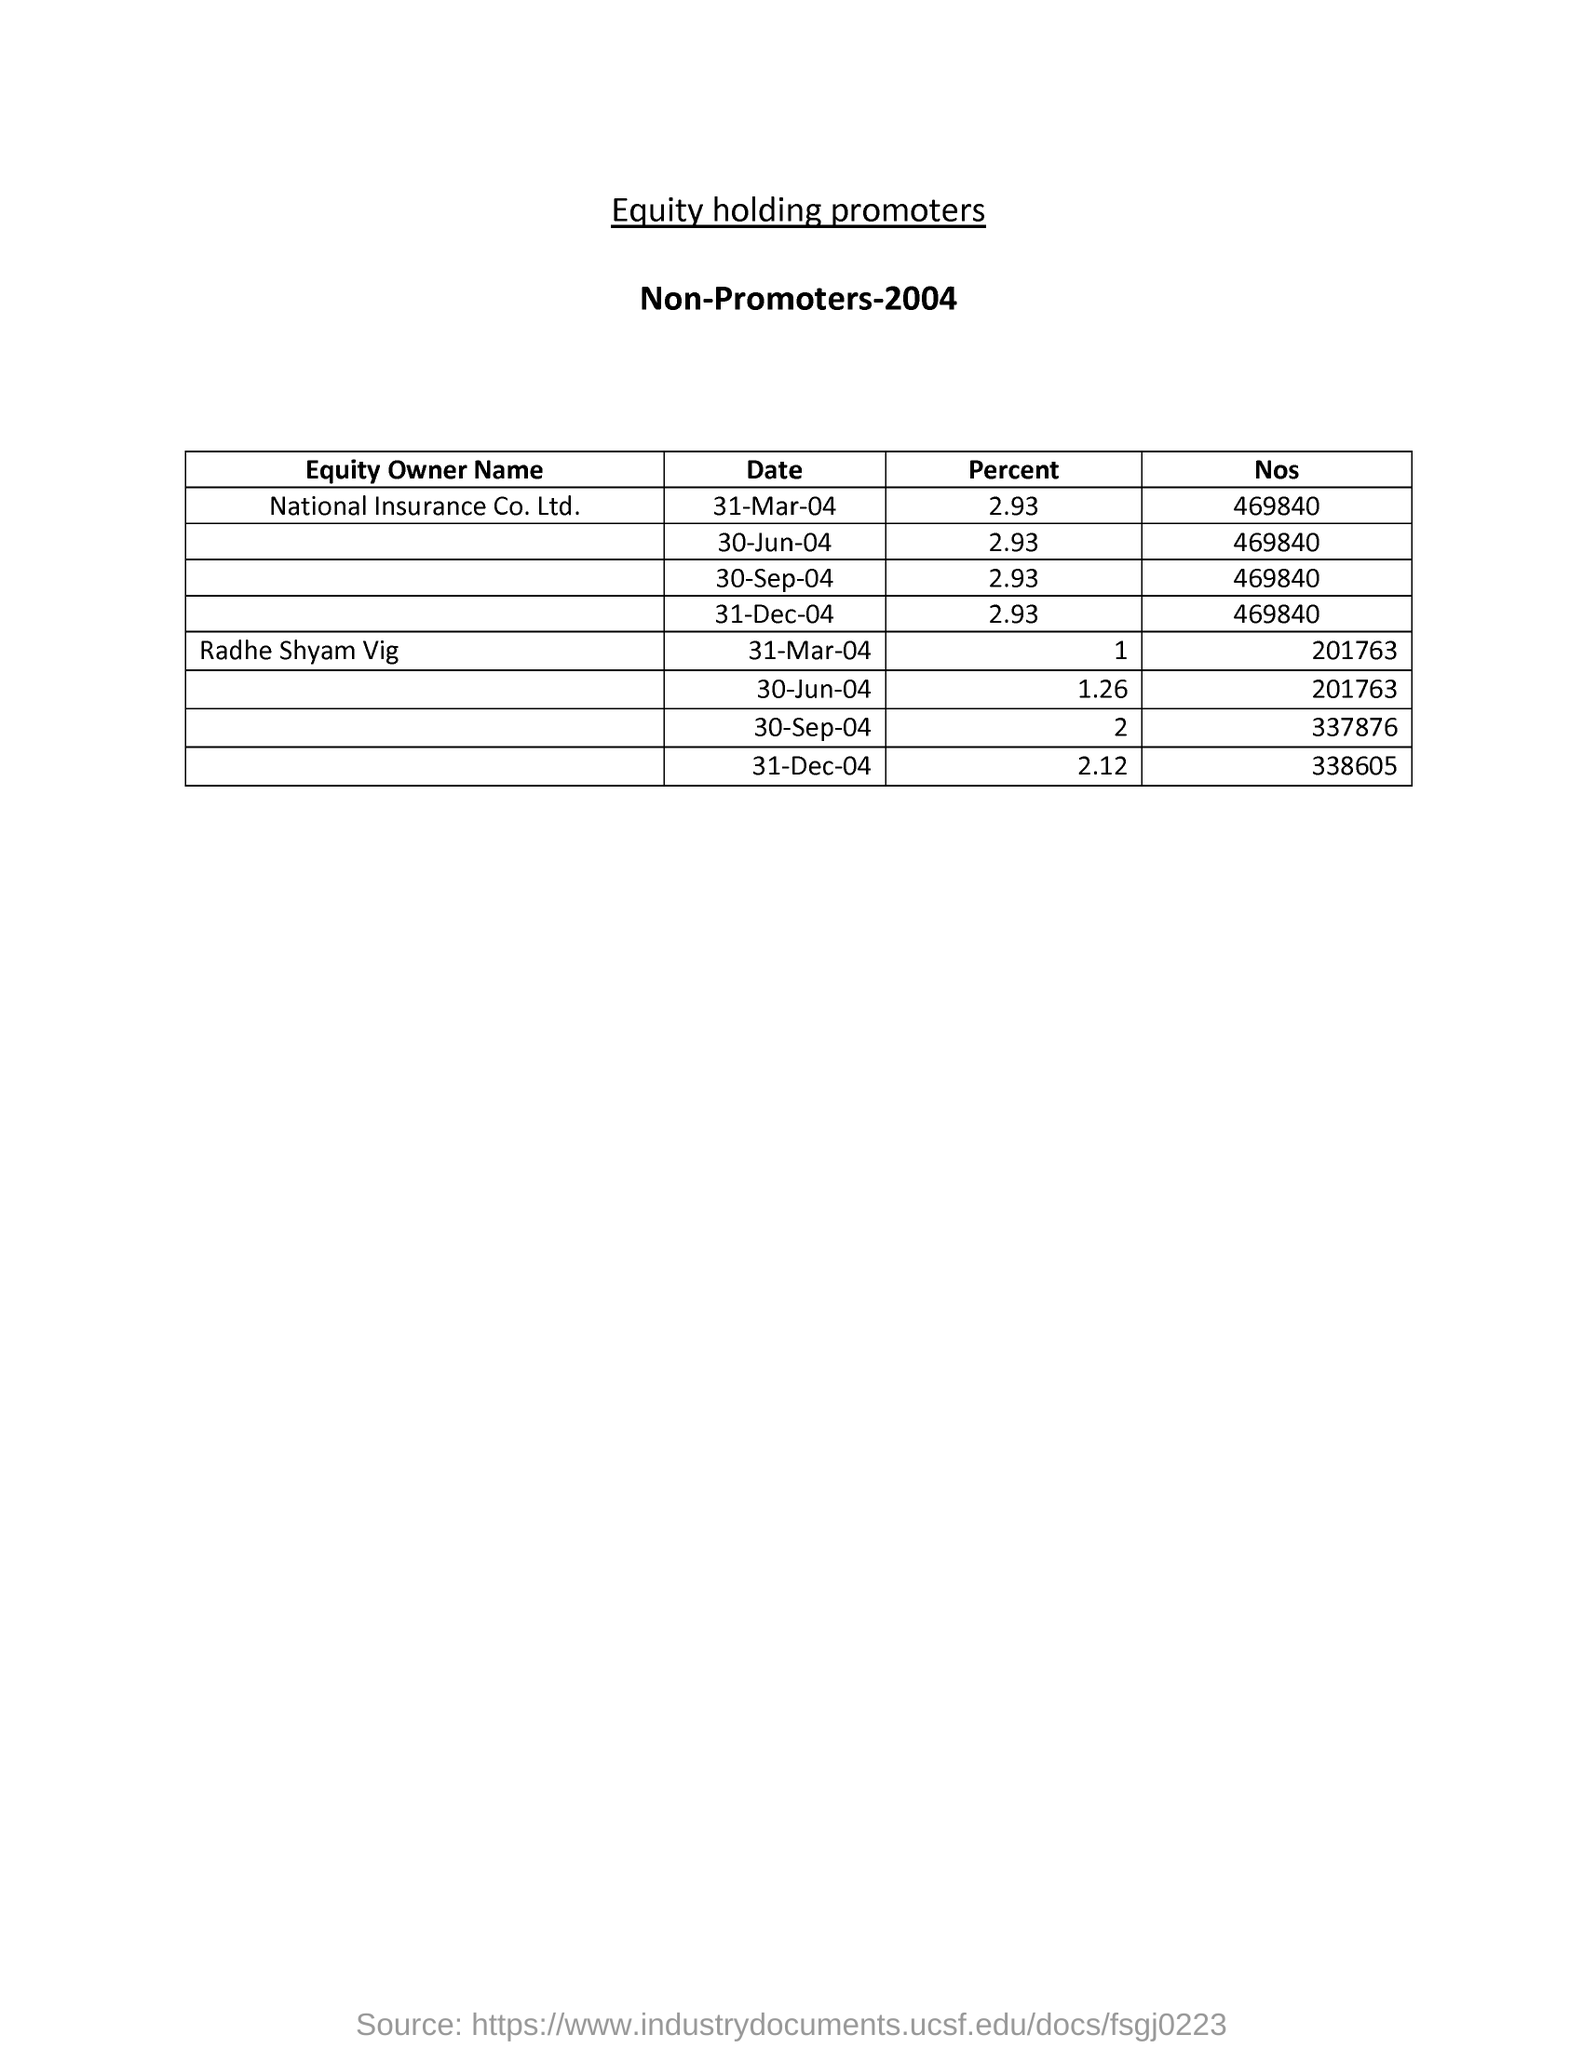Draw attention to some important aspects in this diagram. On March 31, 2004, the percentage corresponding to National Insurance Co. Ltd. was 2.93%. 